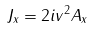Convert formula to latex. <formula><loc_0><loc_0><loc_500><loc_500>J _ { x } = 2 i v ^ { 2 } A _ { x }</formula> 